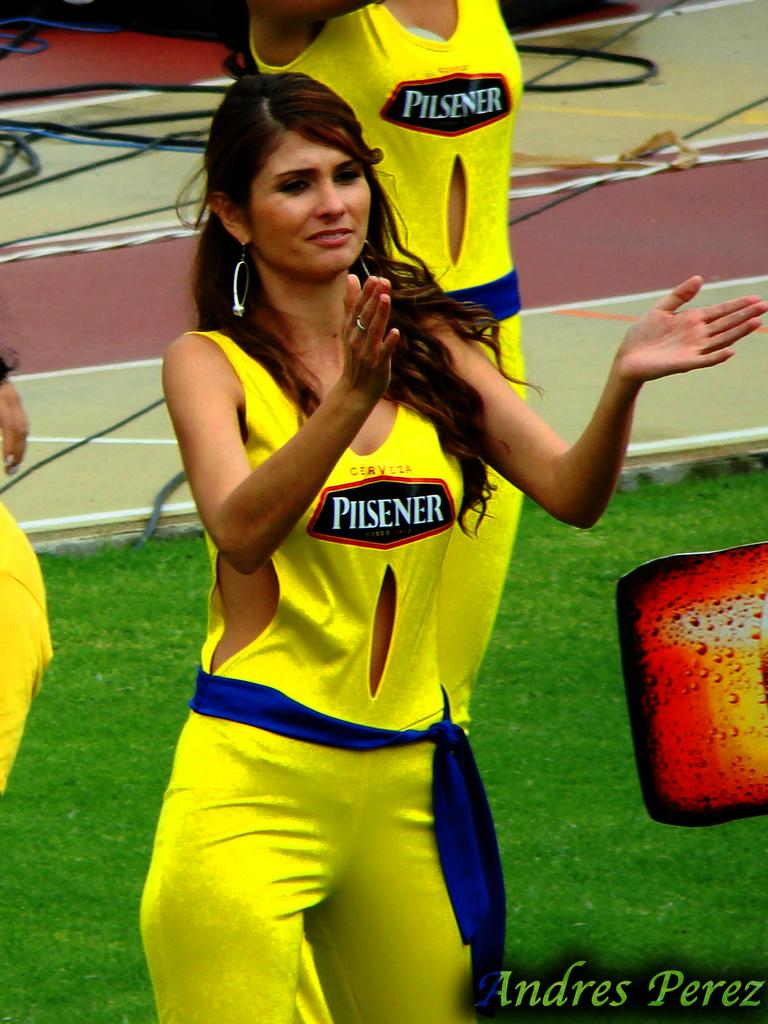<image>
Share a concise interpretation of the image provided. cheerleaders in yellow uniforms with pilsener logo and blue belts 